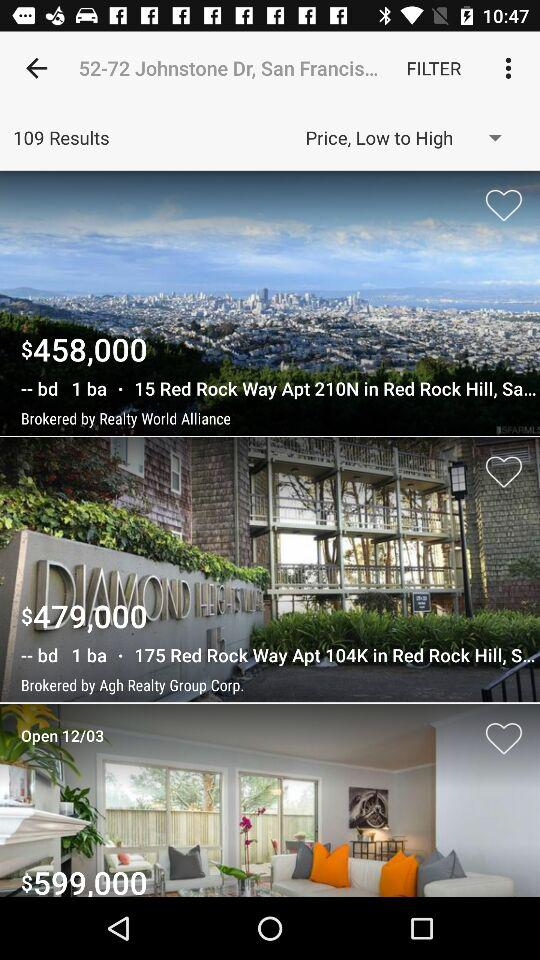What is the address given?
When the provided information is insufficient, respond with <no answer>. <no answer> 